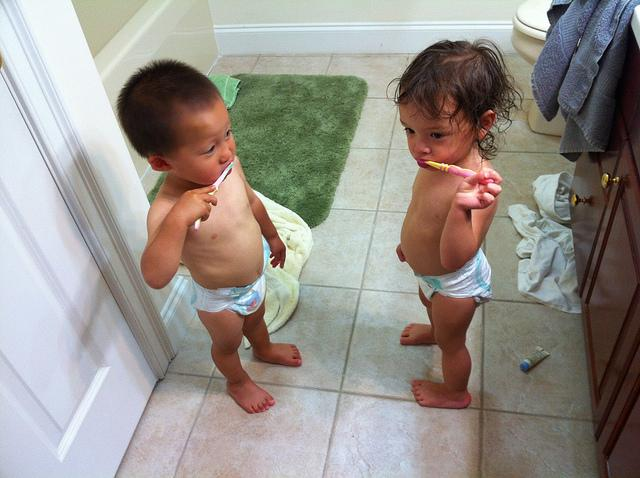How is the kid on the right brushing his teeth differently from the kid on the left? Please explain your reasoning. lefthanded. He is using the hand opposite the other boy. 